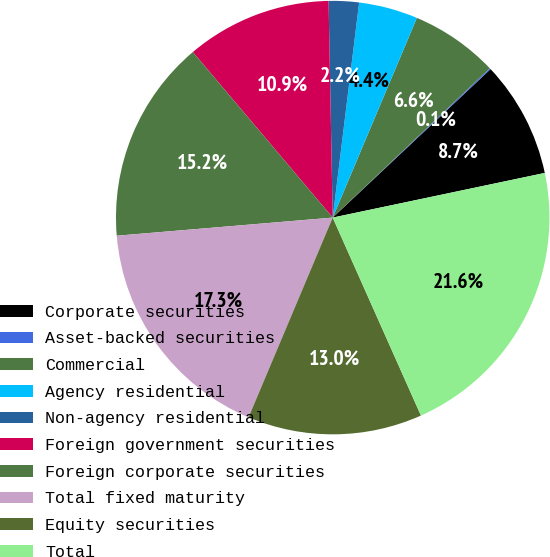<chart> <loc_0><loc_0><loc_500><loc_500><pie_chart><fcel>Corporate securities<fcel>Asset-backed securities<fcel>Commercial<fcel>Agency residential<fcel>Non-agency residential<fcel>Foreign government securities<fcel>Foreign corporate securities<fcel>Total fixed maturity<fcel>Equity securities<fcel>Total<nl><fcel>8.71%<fcel>0.09%<fcel>6.55%<fcel>4.4%<fcel>2.25%<fcel>10.86%<fcel>15.17%<fcel>17.32%<fcel>13.02%<fcel>21.63%<nl></chart> 